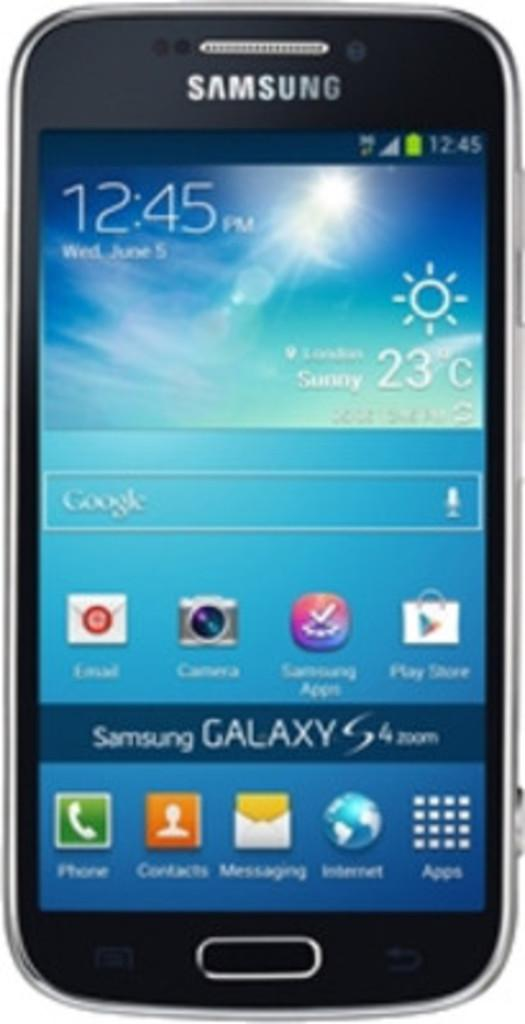What electronic device is shown in the image? There is a mobile phone depicted in the image. What can be seen on the mobile phone's screen? There is text visible on the mobile phone's screen, and there are applications visible as well. Can you see a giraffe drinking from a river in the image? No, there is no giraffe or river present in the image; it features a mobile phone with text and applications on its screen. 